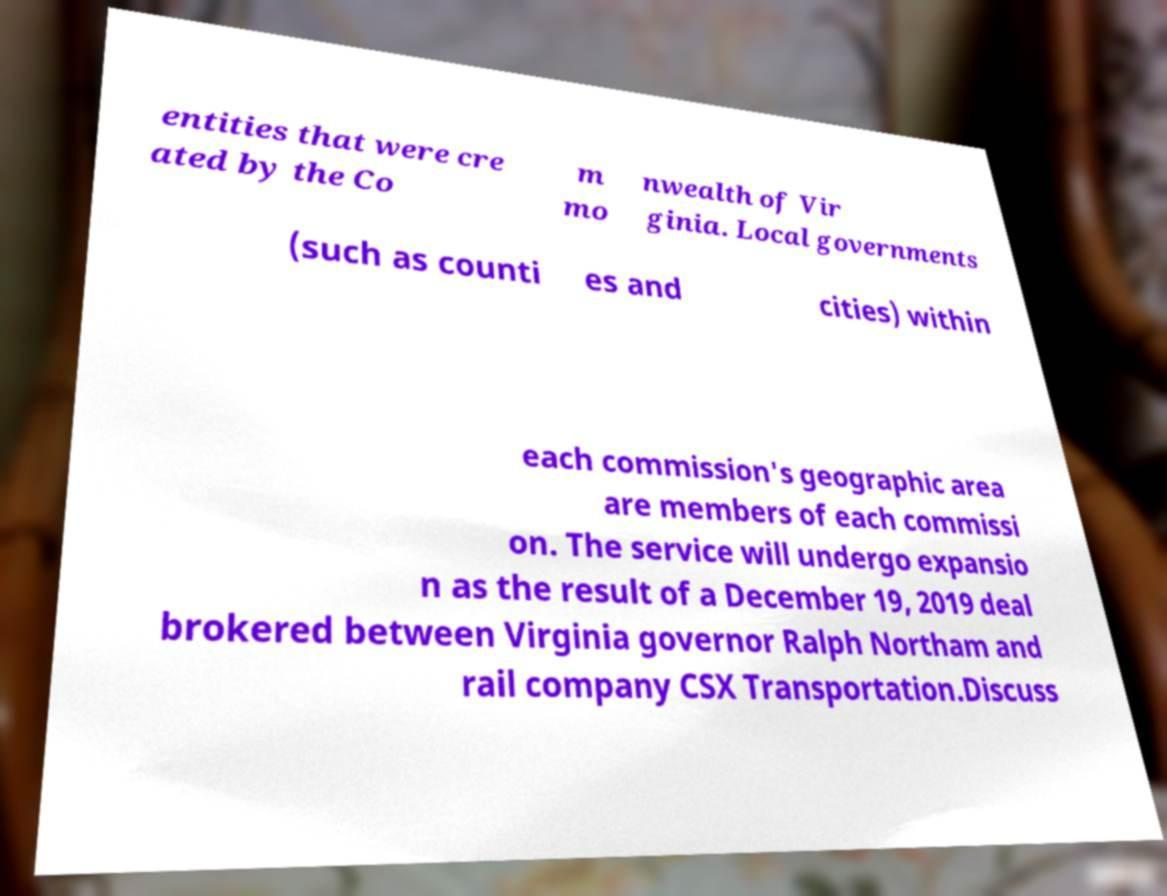For documentation purposes, I need the text within this image transcribed. Could you provide that? entities that were cre ated by the Co m mo nwealth of Vir ginia. Local governments (such as counti es and cities) within each commission's geographic area are members of each commissi on. The service will undergo expansio n as the result of a December 19, 2019 deal brokered between Virginia governor Ralph Northam and rail company CSX Transportation.Discuss 